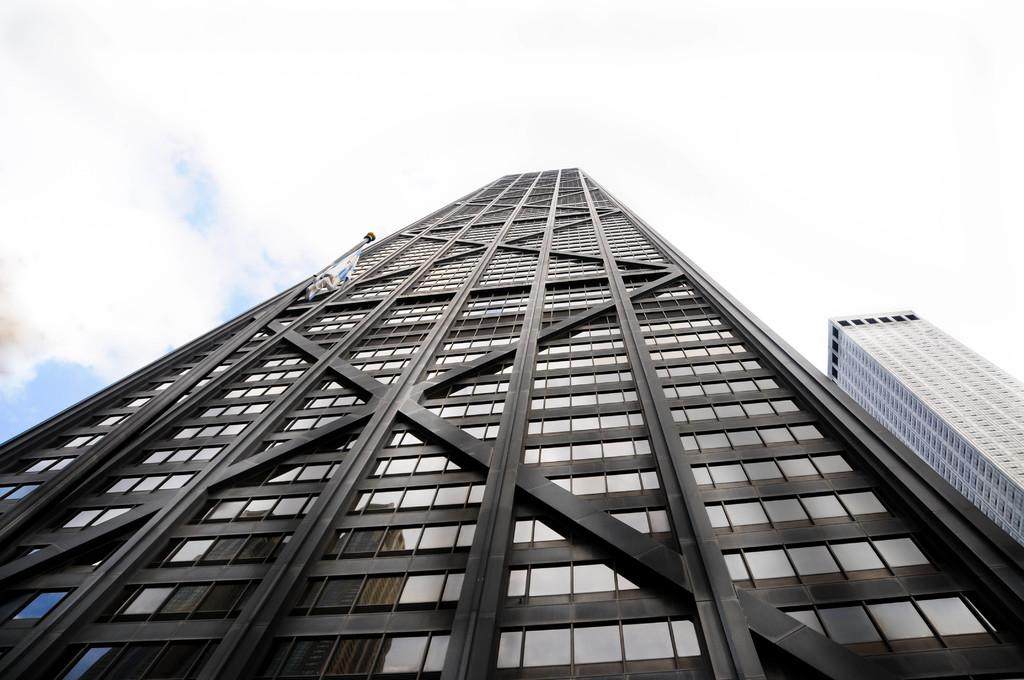What type of structures can be seen in the image? There are buildings in the image. What can be seen in the sky in the image? There are clouds visible in the image. What type of pin can be seen piercing a vein in the image? There is no pin or vein present in the image; it only features buildings and clouds. 